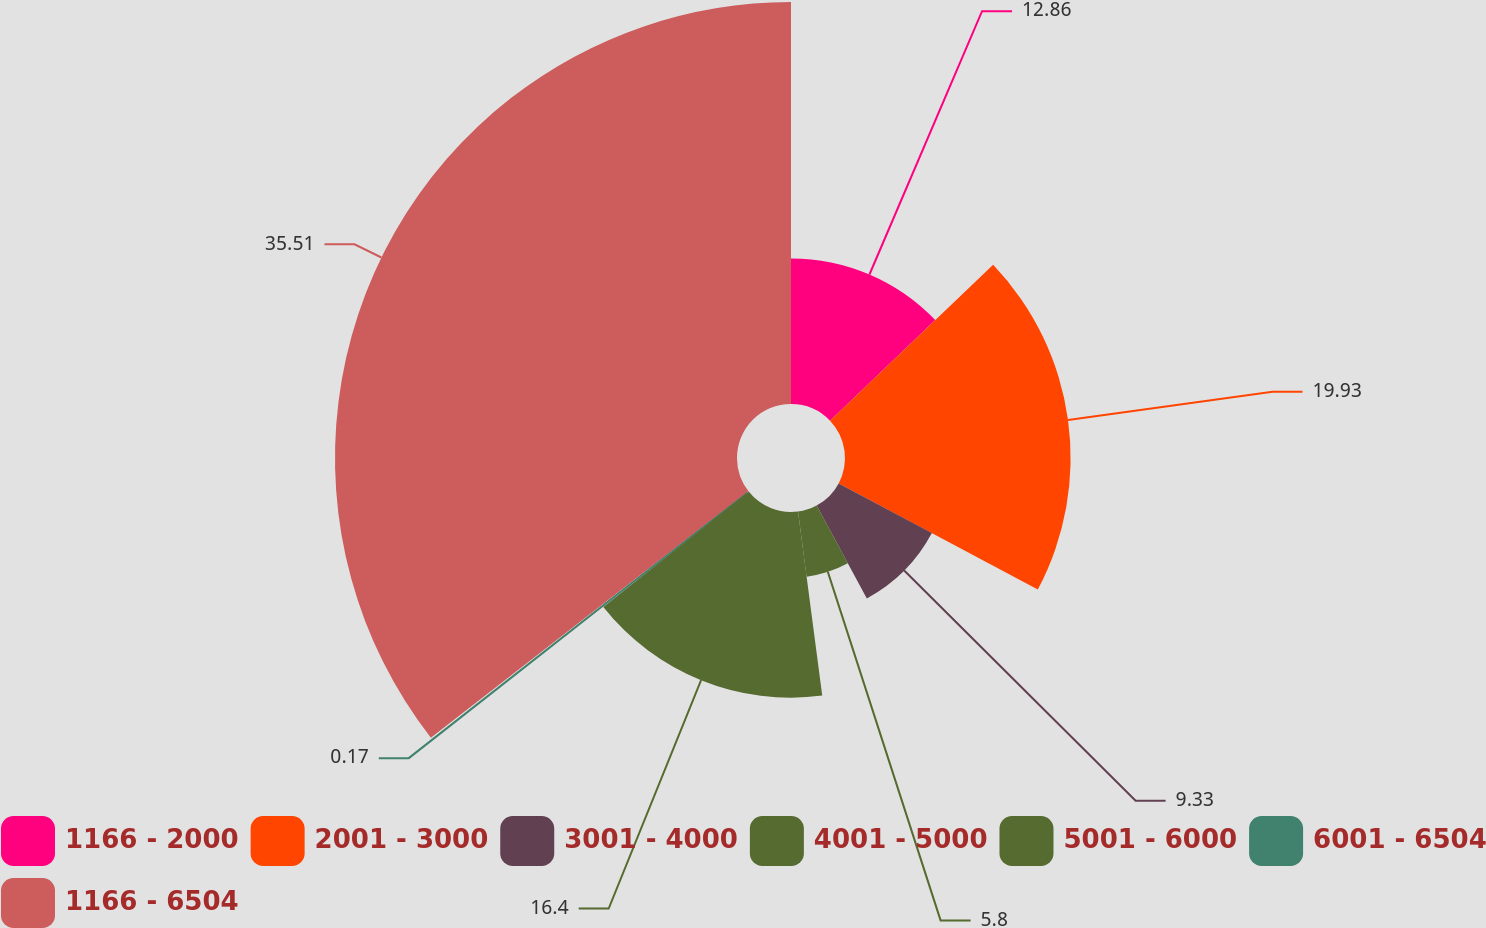Convert chart. <chart><loc_0><loc_0><loc_500><loc_500><pie_chart><fcel>1166 - 2000<fcel>2001 - 3000<fcel>3001 - 4000<fcel>4001 - 5000<fcel>5001 - 6000<fcel>6001 - 6504<fcel>1166 - 6504<nl><fcel>12.86%<fcel>19.93%<fcel>9.33%<fcel>5.8%<fcel>16.4%<fcel>0.17%<fcel>35.51%<nl></chart> 